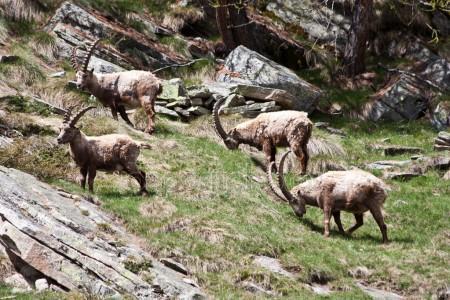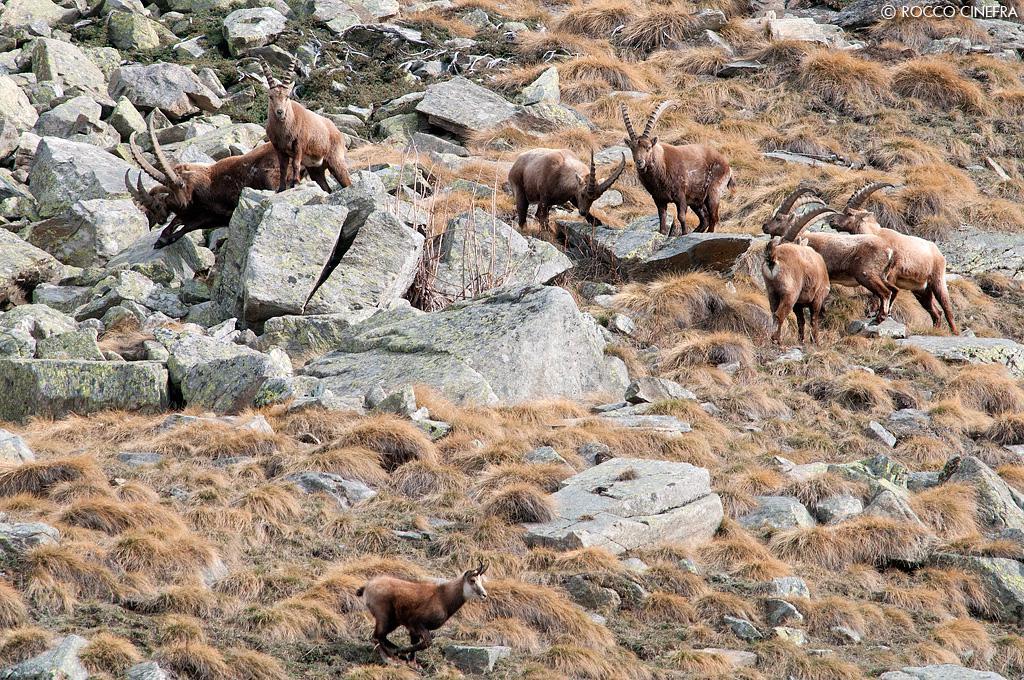The first image is the image on the left, the second image is the image on the right. For the images shown, is this caption "At least one of the images contains exactly two antelopes." true? Answer yes or no. No. The first image is the image on the left, the second image is the image on the right. Assess this claim about the two images: "There are exactly four animals in the image on the left.". Correct or not? Answer yes or no. Yes. 